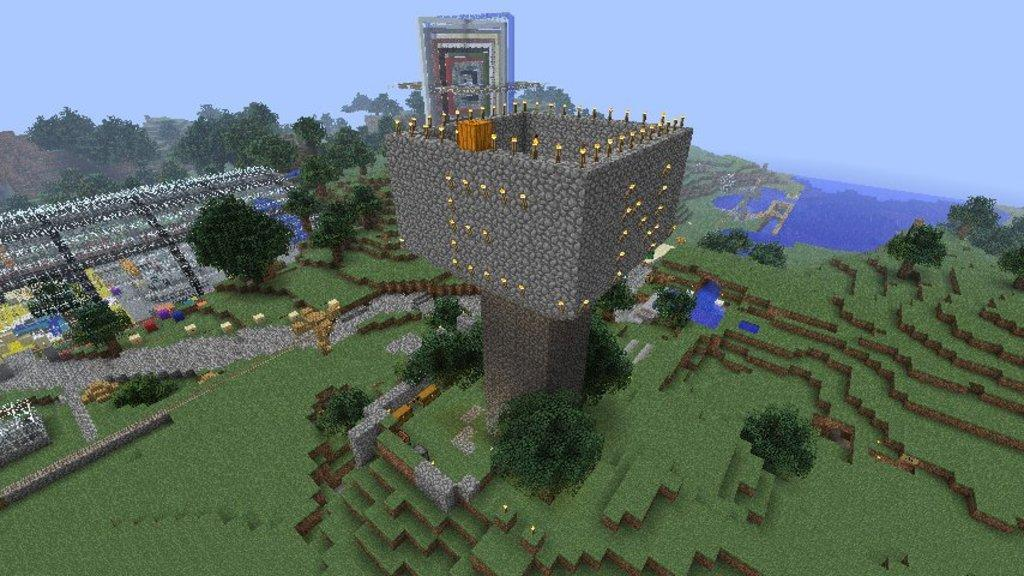What type of image is present in the picture? There is an animated image in the picture. What can be seen on the right side of the image? There is a sea at the right side of the image. What type of vegetation is visible in the image? There are trees visible in the image. What is the condition of the sky in the image? The sky is clear in the image. What type of hat is the bird wearing in the image? There is no bird or hat present in the image; it features an animated image with a sea, trees, and a clear sky. 